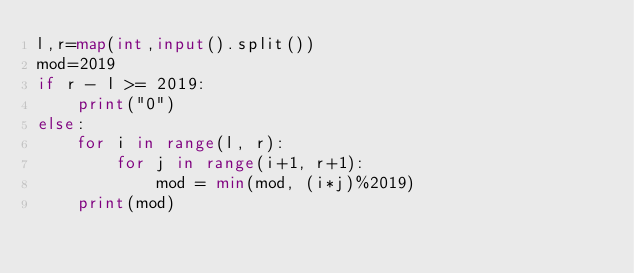<code> <loc_0><loc_0><loc_500><loc_500><_Python_>l,r=map(int,input().split())
mod=2019
if r - l >= 2019:
    print("0")
else:
    for i in range(l, r):
        for j in range(i+1, r+1):
            mod = min(mod, (i*j)%2019)
    print(mod)</code> 